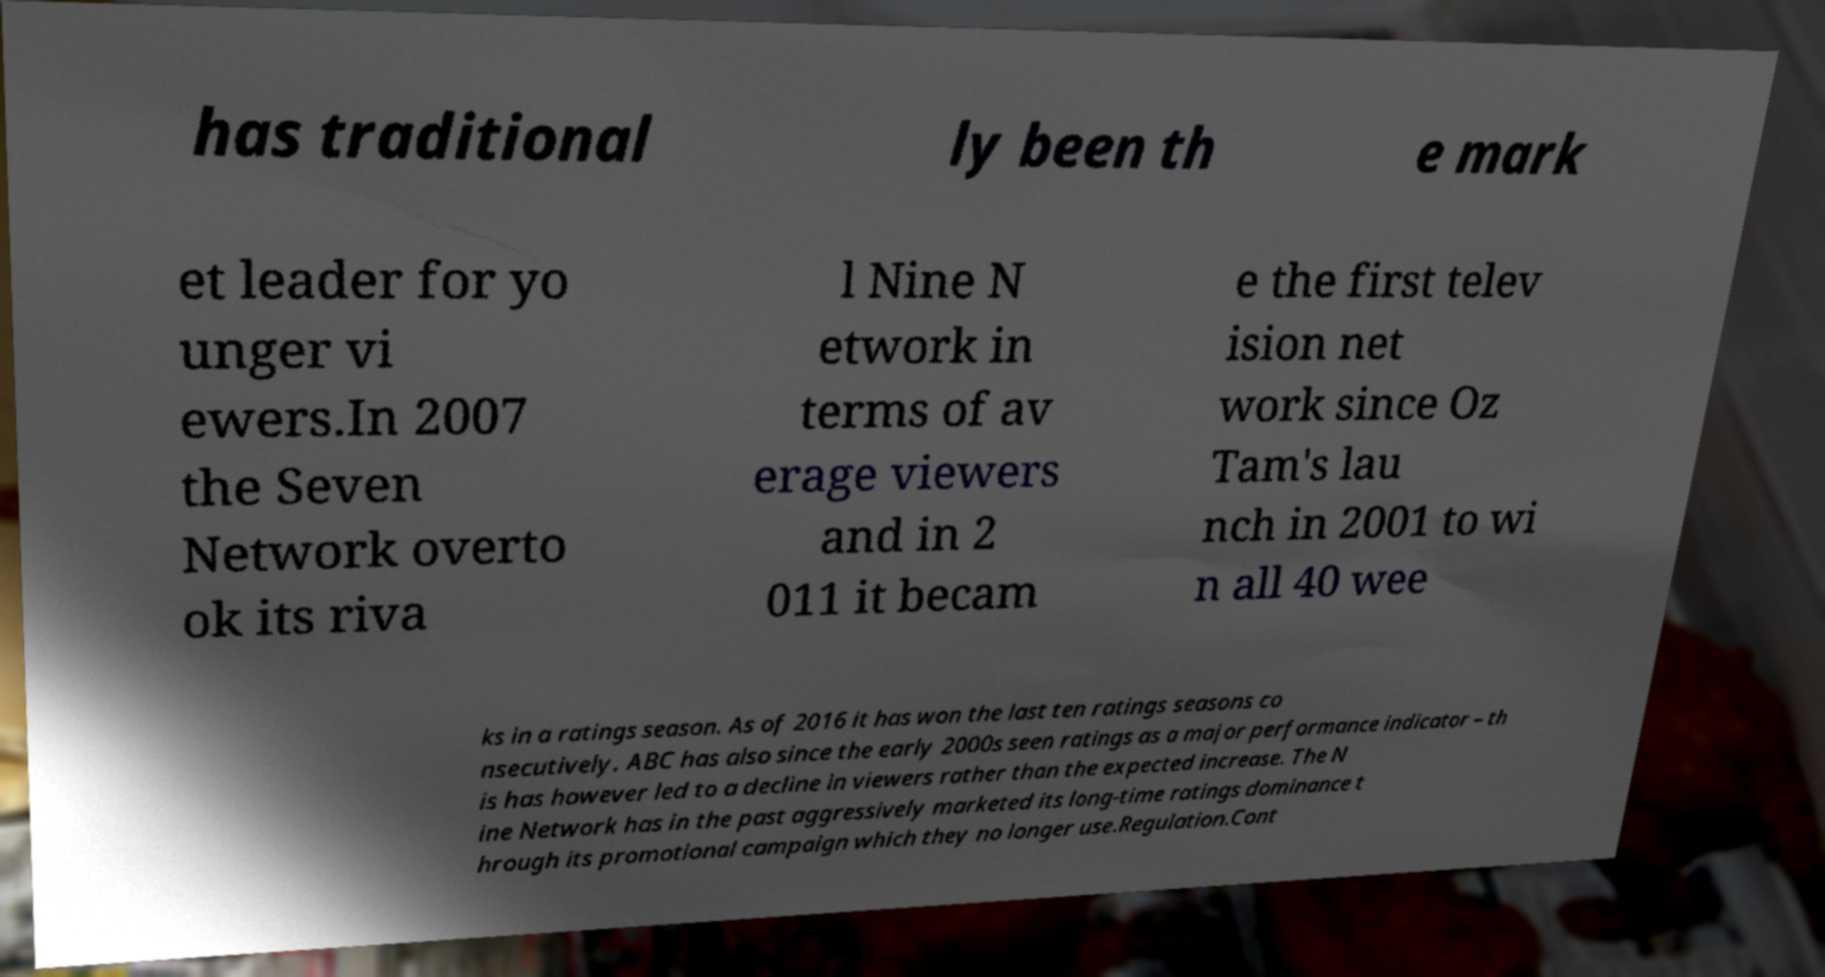Could you extract and type out the text from this image? has traditional ly been th e mark et leader for yo unger vi ewers.In 2007 the Seven Network overto ok its riva l Nine N etwork in terms of av erage viewers and in 2 011 it becam e the first telev ision net work since Oz Tam's lau nch in 2001 to wi n all 40 wee ks in a ratings season. As of 2016 it has won the last ten ratings seasons co nsecutively. ABC has also since the early 2000s seen ratings as a major performance indicator – th is has however led to a decline in viewers rather than the expected increase. The N ine Network has in the past aggressively marketed its long-time ratings dominance t hrough its promotional campaign which they no longer use.Regulation.Cont 